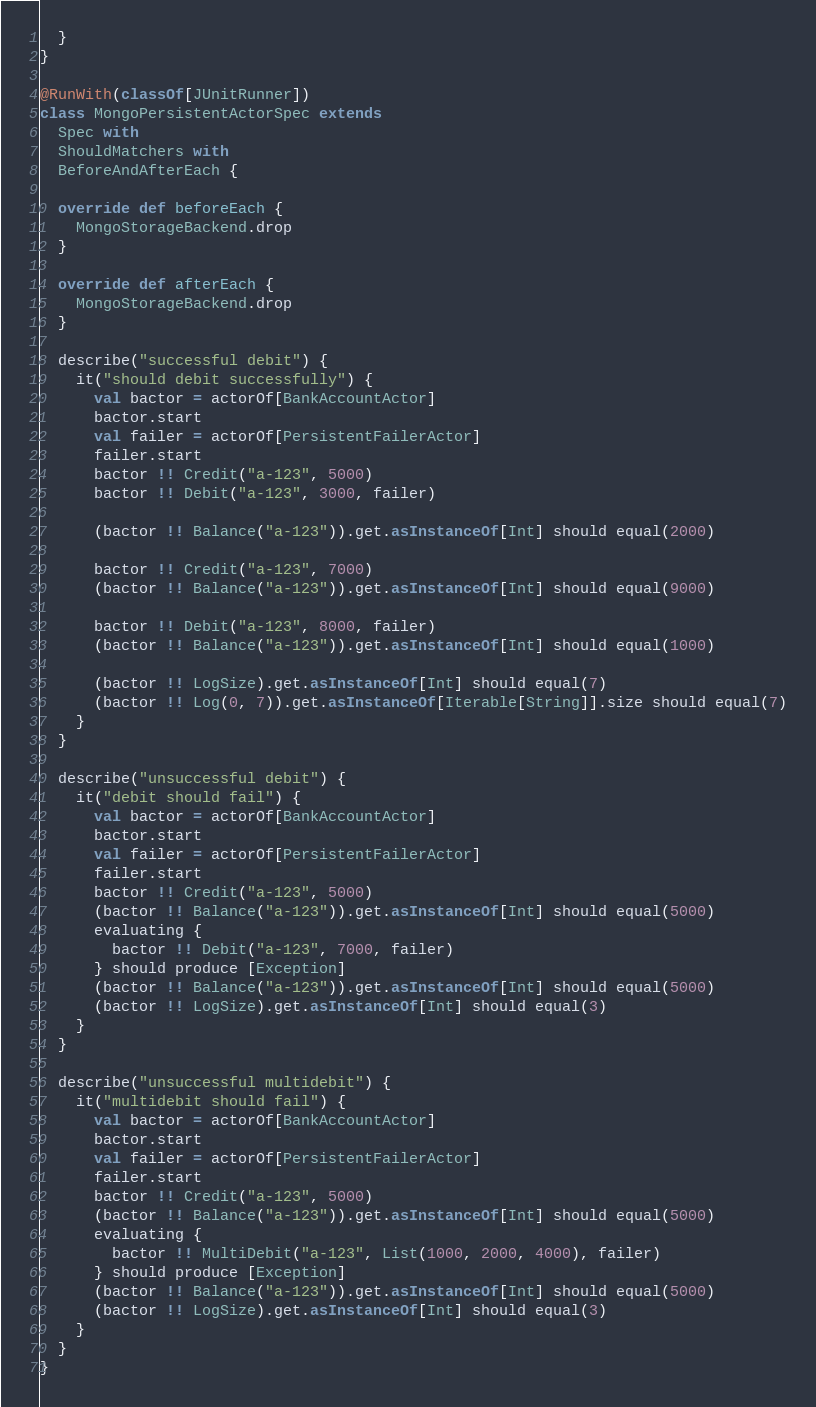<code> <loc_0><loc_0><loc_500><loc_500><_Scala_>  }
}

@RunWith(classOf[JUnitRunner])
class MongoPersistentActorSpec extends
  Spec with
  ShouldMatchers with
  BeforeAndAfterEach {

  override def beforeEach {
    MongoStorageBackend.drop
  }

  override def afterEach {
    MongoStorageBackend.drop
  }

  describe("successful debit") {
    it("should debit successfully") {
      val bactor = actorOf[BankAccountActor]
      bactor.start
      val failer = actorOf[PersistentFailerActor]
      failer.start
      bactor !! Credit("a-123", 5000)
      bactor !! Debit("a-123", 3000, failer)

      (bactor !! Balance("a-123")).get.asInstanceOf[Int] should equal(2000)

      bactor !! Credit("a-123", 7000)
      (bactor !! Balance("a-123")).get.asInstanceOf[Int] should equal(9000)

      bactor !! Debit("a-123", 8000, failer)
      (bactor !! Balance("a-123")).get.asInstanceOf[Int] should equal(1000)

      (bactor !! LogSize).get.asInstanceOf[Int] should equal(7)
      (bactor !! Log(0, 7)).get.asInstanceOf[Iterable[String]].size should equal(7)
    }
  }

  describe("unsuccessful debit") {
    it("debit should fail") {
      val bactor = actorOf[BankAccountActor]
      bactor.start
      val failer = actorOf[PersistentFailerActor]
      failer.start
      bactor !! Credit("a-123", 5000)
      (bactor !! Balance("a-123")).get.asInstanceOf[Int] should equal(5000)
      evaluating {
        bactor !! Debit("a-123", 7000, failer)
      } should produce [Exception]
      (bactor !! Balance("a-123")).get.asInstanceOf[Int] should equal(5000)
      (bactor !! LogSize).get.asInstanceOf[Int] should equal(3)
    }
  }

  describe("unsuccessful multidebit") {
    it("multidebit should fail") {
      val bactor = actorOf[BankAccountActor]
      bactor.start
      val failer = actorOf[PersistentFailerActor]
      failer.start
      bactor !! Credit("a-123", 5000)
      (bactor !! Balance("a-123")).get.asInstanceOf[Int] should equal(5000)
      evaluating {
        bactor !! MultiDebit("a-123", List(1000, 2000, 4000), failer)
      } should produce [Exception]
      (bactor !! Balance("a-123")).get.asInstanceOf[Int] should equal(5000)
      (bactor !! LogSize).get.asInstanceOf[Int] should equal(3)
    }
  }
}
</code> 